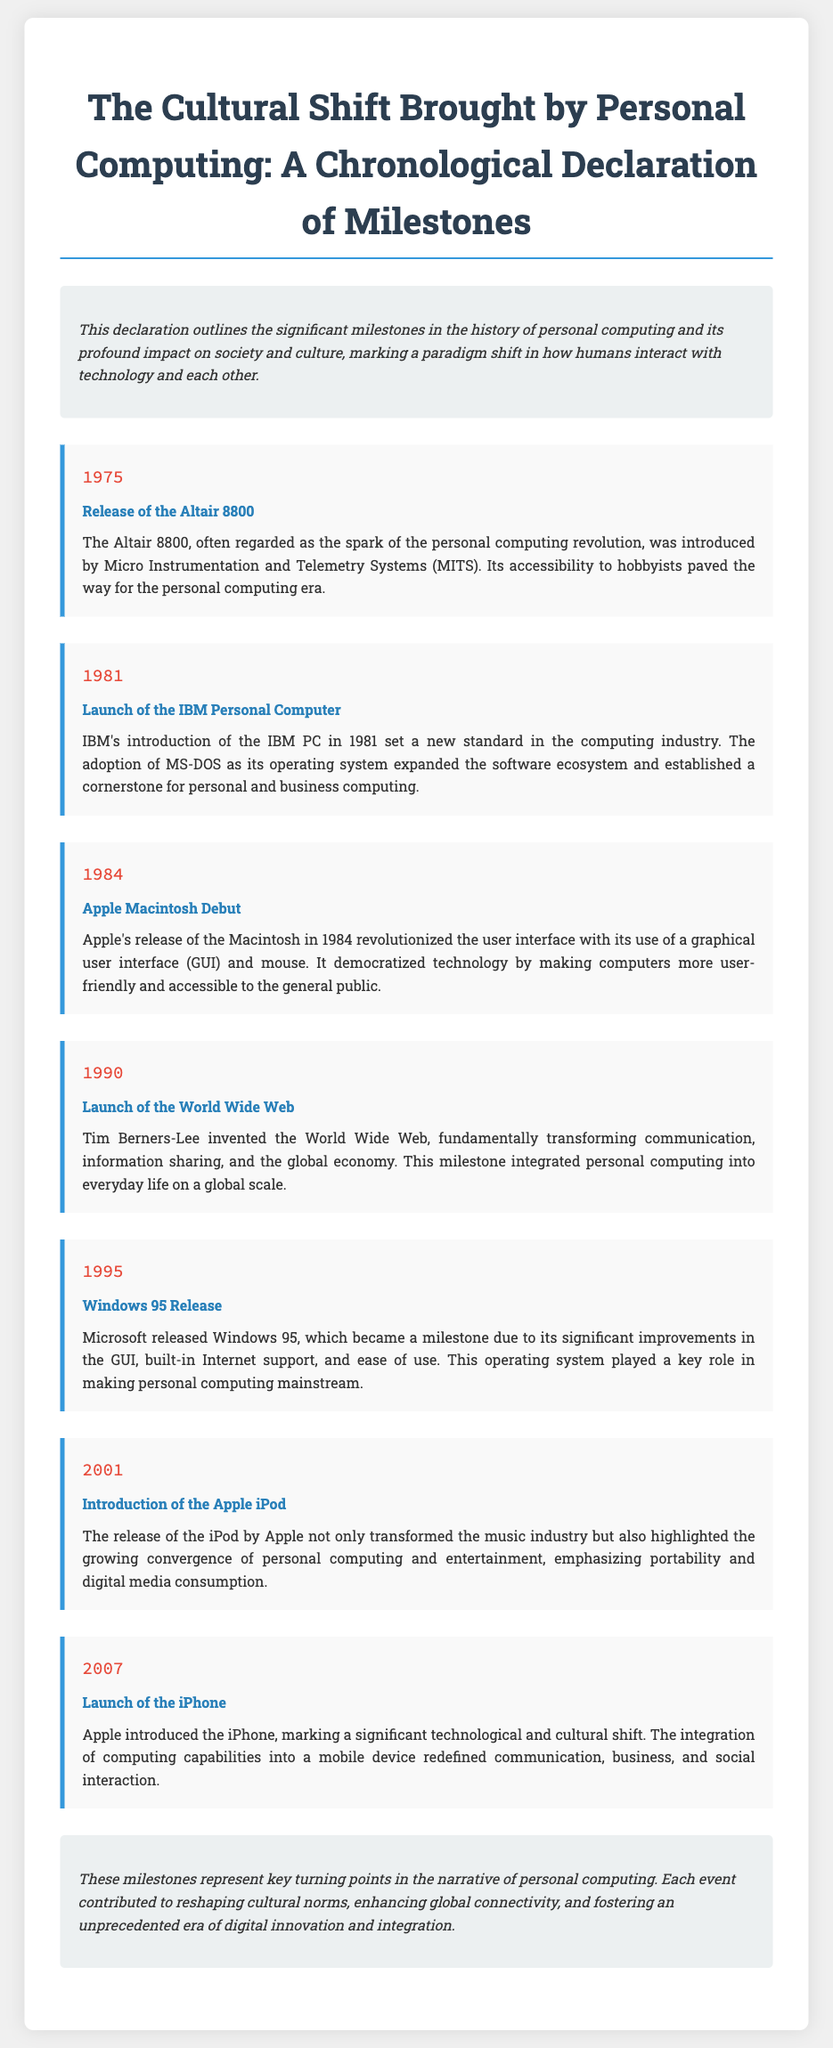What year was the Altair 8800 released? The Altair 8800 was introduced in 1975, marking the beginning of the personal computing revolution.
Answer: 1975 What significant event happened in 1984? The Apple Macintosh debuted in 1984, revolutionizing the user interface with its graphical user interface and mouse.
Answer: Apple Macintosh Debut Who invented the World Wide Web? The World Wide Web was invented by Tim Berners-Lee in 1990, transforming communication and information sharing.
Answer: Tim Berners-Lee Which operating system was released in 1995? Windows 95 was released by Microsoft in 1995, significantly improving user-friendliness and Internet support.
Answer: Windows 95 Release What did the introduction of the iPhone signify? The launch of the iPhone in 2007 marked a technological and cultural shift by integrating computing capabilities into a mobile device.
Answer: Significant technological and cultural shift What was the main impact of the release of the iPod in 2001? The iPod transformed the music industry and highlighted the convergence of personal computing and entertainment.
Answer: Transformed the music industry What is the overall theme of the declaration? The declaration outlines significant milestones in personal computing and its impact on society and culture.
Answer: Cultural shift brought by personal computing What milestone is recognized as the spark of the personal computing revolution? The Altair 8800 is recognized as the spark of the personal computing revolution.
Answer: Altair 8800 